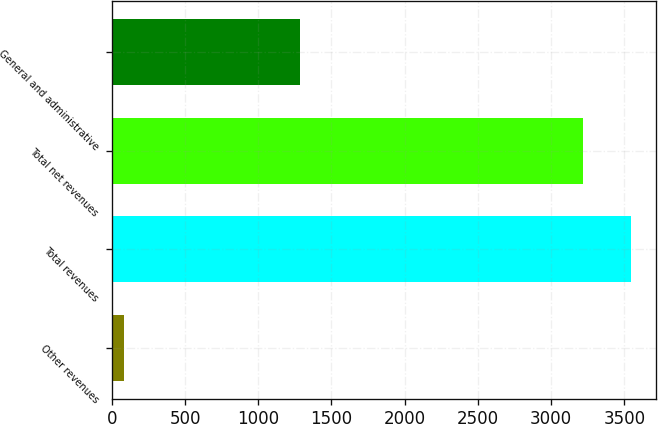Convert chart. <chart><loc_0><loc_0><loc_500><loc_500><bar_chart><fcel>Other revenues<fcel>Total revenues<fcel>Total net revenues<fcel>General and administrative<nl><fcel>85<fcel>3542.4<fcel>3216<fcel>1282<nl></chart> 